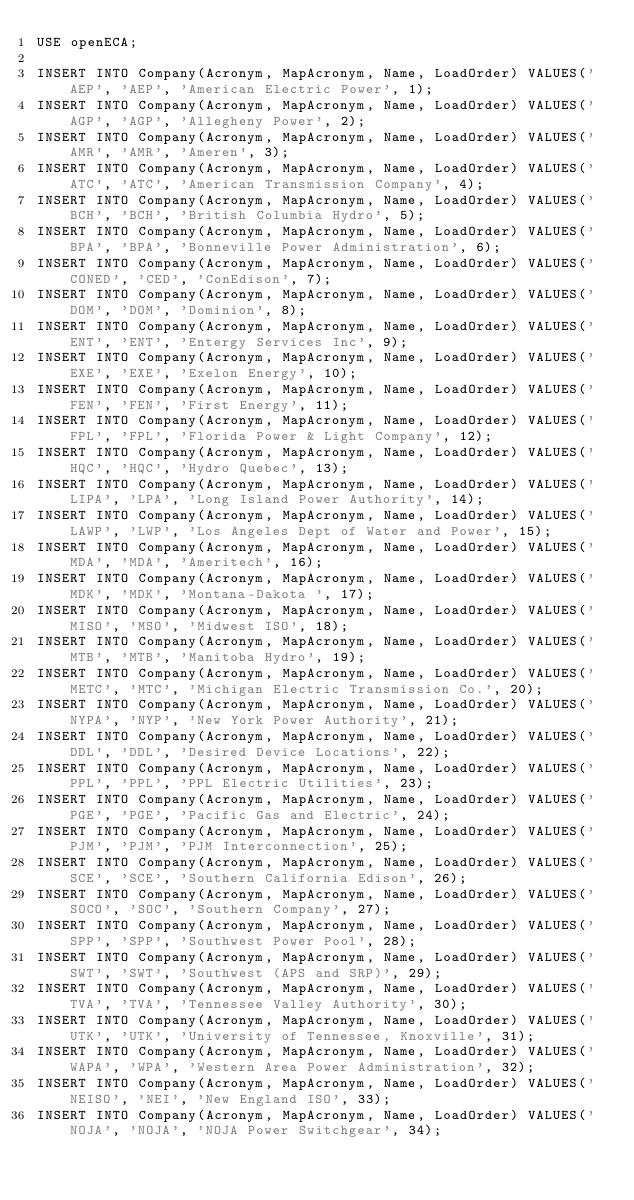Convert code to text. <code><loc_0><loc_0><loc_500><loc_500><_SQL_>USE openECA;

INSERT INTO Company(Acronym, MapAcronym, Name, LoadOrder) VALUES('AEP', 'AEP', 'American Electric Power', 1);
INSERT INTO Company(Acronym, MapAcronym, Name, LoadOrder) VALUES('AGP', 'AGP', 'Allegheny Power', 2);
INSERT INTO Company(Acronym, MapAcronym, Name, LoadOrder) VALUES('AMR', 'AMR', 'Ameren', 3);
INSERT INTO Company(Acronym, MapAcronym, Name, LoadOrder) VALUES('ATC', 'ATC', 'American Transmission Company', 4);
INSERT INTO Company(Acronym, MapAcronym, Name, LoadOrder) VALUES('BCH', 'BCH', 'British Columbia Hydro', 5);
INSERT INTO Company(Acronym, MapAcronym, Name, LoadOrder) VALUES('BPA', 'BPA', 'Bonneville Power Administration', 6);
INSERT INTO Company(Acronym, MapAcronym, Name, LoadOrder) VALUES('CONED', 'CED', 'ConEdison', 7);
INSERT INTO Company(Acronym, MapAcronym, Name, LoadOrder) VALUES('DOM', 'DOM', 'Dominion', 8);
INSERT INTO Company(Acronym, MapAcronym, Name, LoadOrder) VALUES('ENT', 'ENT', 'Entergy Services Inc', 9);
INSERT INTO Company(Acronym, MapAcronym, Name, LoadOrder) VALUES('EXE', 'EXE', 'Exelon Energy', 10);
INSERT INTO Company(Acronym, MapAcronym, Name, LoadOrder) VALUES('FEN', 'FEN', 'First Energy', 11);
INSERT INTO Company(Acronym, MapAcronym, Name, LoadOrder) VALUES('FPL', 'FPL', 'Florida Power & Light Company', 12);
INSERT INTO Company(Acronym, MapAcronym, Name, LoadOrder) VALUES('HQC', 'HQC', 'Hydro Quebec', 13);
INSERT INTO Company(Acronym, MapAcronym, Name, LoadOrder) VALUES('LIPA', 'LPA', 'Long Island Power Authority', 14);
INSERT INTO Company(Acronym, MapAcronym, Name, LoadOrder) VALUES('LAWP', 'LWP', 'Los Angeles Dept of Water and Power', 15);
INSERT INTO Company(Acronym, MapAcronym, Name, LoadOrder) VALUES('MDA', 'MDA', 'Ameritech', 16);
INSERT INTO Company(Acronym, MapAcronym, Name, LoadOrder) VALUES('MDK', 'MDK', 'Montana-Dakota ', 17);
INSERT INTO Company(Acronym, MapAcronym, Name, LoadOrder) VALUES('MISO', 'MSO', 'Midwest ISO', 18);
INSERT INTO Company(Acronym, MapAcronym, Name, LoadOrder) VALUES('MTB', 'MTB', 'Manitoba Hydro', 19);
INSERT INTO Company(Acronym, MapAcronym, Name, LoadOrder) VALUES('METC', 'MTC', 'Michigan Electric Transmission Co.', 20);
INSERT INTO Company(Acronym, MapAcronym, Name, LoadOrder) VALUES('NYPA', 'NYP', 'New York Power Authority', 21);
INSERT INTO Company(Acronym, MapAcronym, Name, LoadOrder) VALUES('DDL', 'DDL', 'Desired Device Locations', 22);
INSERT INTO Company(Acronym, MapAcronym, Name, LoadOrder) VALUES('PPL', 'PPL', 'PPL Electric Utilities', 23);
INSERT INTO Company(Acronym, MapAcronym, Name, LoadOrder) VALUES('PGE', 'PGE', 'Pacific Gas and Electric', 24);
INSERT INTO Company(Acronym, MapAcronym, Name, LoadOrder) VALUES('PJM', 'PJM', 'PJM Interconnection', 25);
INSERT INTO Company(Acronym, MapAcronym, Name, LoadOrder) VALUES('SCE', 'SCE', 'Southern California Edison', 26);
INSERT INTO Company(Acronym, MapAcronym, Name, LoadOrder) VALUES('SOCO', 'SOC', 'Southern Company', 27);
INSERT INTO Company(Acronym, MapAcronym, Name, LoadOrder) VALUES('SPP', 'SPP', 'Southwest Power Pool', 28);
INSERT INTO Company(Acronym, MapAcronym, Name, LoadOrder) VALUES('SWT', 'SWT', 'Southwest (APS and SRP)', 29);
INSERT INTO Company(Acronym, MapAcronym, Name, LoadOrder) VALUES('TVA', 'TVA', 'Tennessee Valley Authority', 30);
INSERT INTO Company(Acronym, MapAcronym, Name, LoadOrder) VALUES('UTK', 'UTK', 'University of Tennessee, Knoxville', 31);
INSERT INTO Company(Acronym, MapAcronym, Name, LoadOrder) VALUES('WAPA', 'WPA', 'Western Area Power Administration', 32);
INSERT INTO Company(Acronym, MapAcronym, Name, LoadOrder) VALUES('NEISO', 'NEI', 'New England ISO', 33);
INSERT INTO Company(Acronym, MapAcronym, Name, LoadOrder) VALUES('NOJA', 'NOJA', 'NOJA Power Switchgear', 34);</code> 